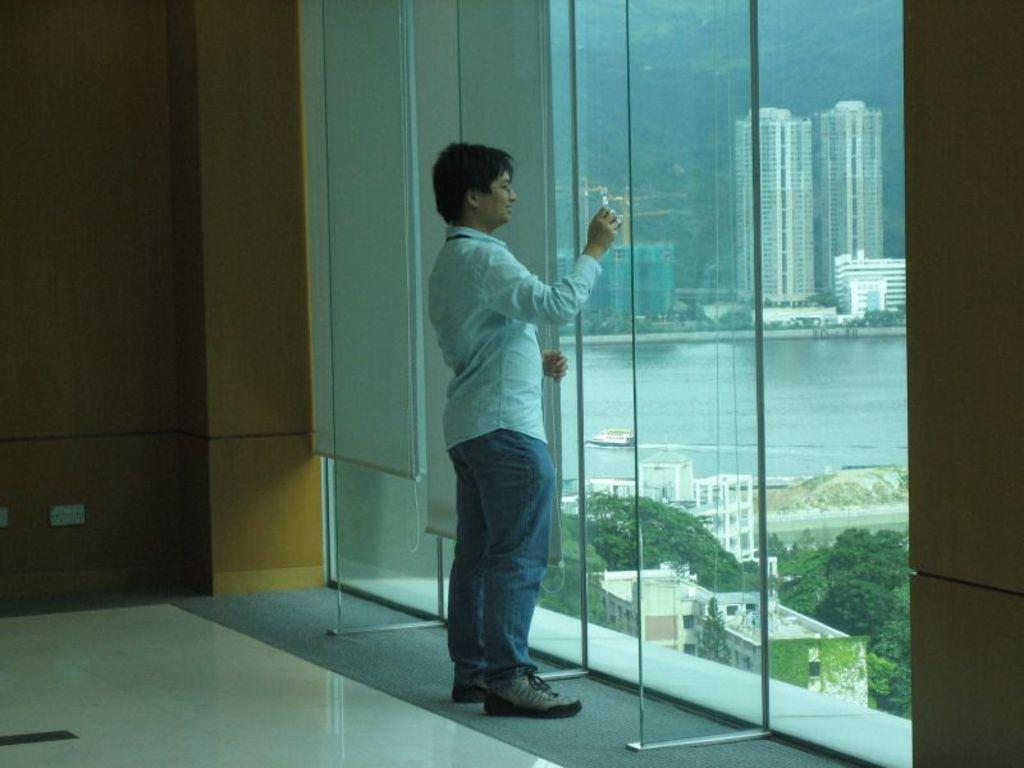Please provide a concise description of this image. As we can see in the image there is a wall, a man wearing white color shirt and out side the window there are trees, water, boat and buildings. 